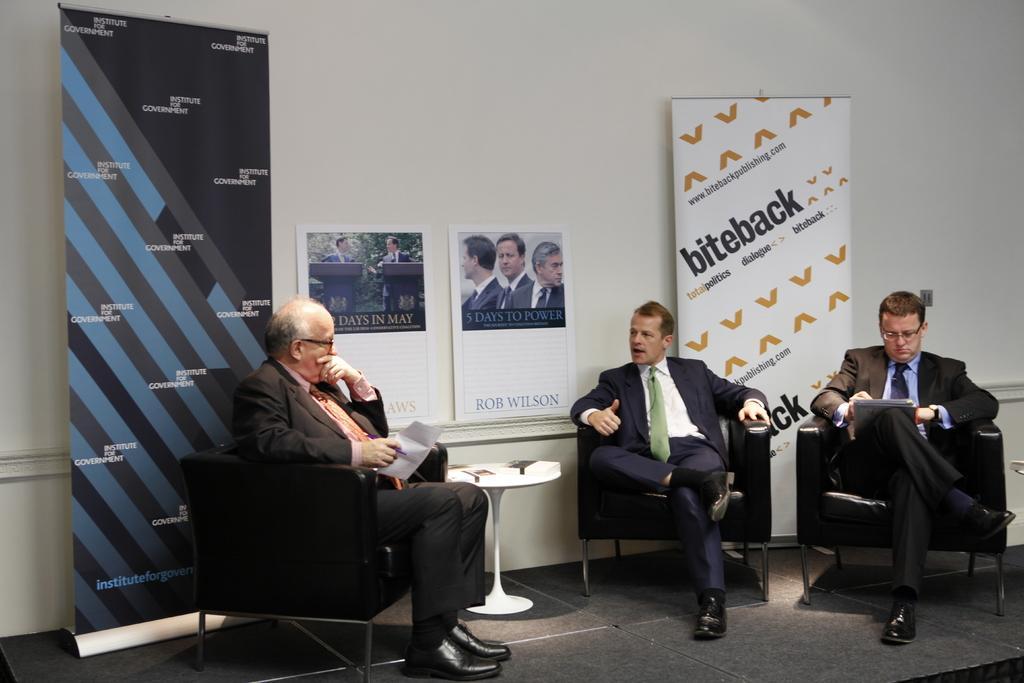How would you summarize this image in a sentence or two? In this image I can see there are three men who are sitting on a chair in front of a table on the floor. 